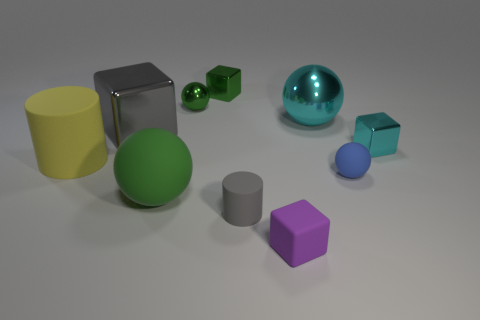Subtract all big green spheres. How many spheres are left? 3 Subtract all cyan spheres. How many spheres are left? 3 Subtract 1 cylinders. How many cylinders are left? 1 Subtract all red spheres. Subtract all purple blocks. How many spheres are left? 4 Subtract all red spheres. How many gray cylinders are left? 1 Subtract all small cyan objects. Subtract all tiny matte balls. How many objects are left? 8 Add 2 small blue matte things. How many small blue matte things are left? 3 Add 2 green shiny balls. How many green shiny balls exist? 3 Subtract 0 purple spheres. How many objects are left? 10 Subtract all balls. How many objects are left? 6 